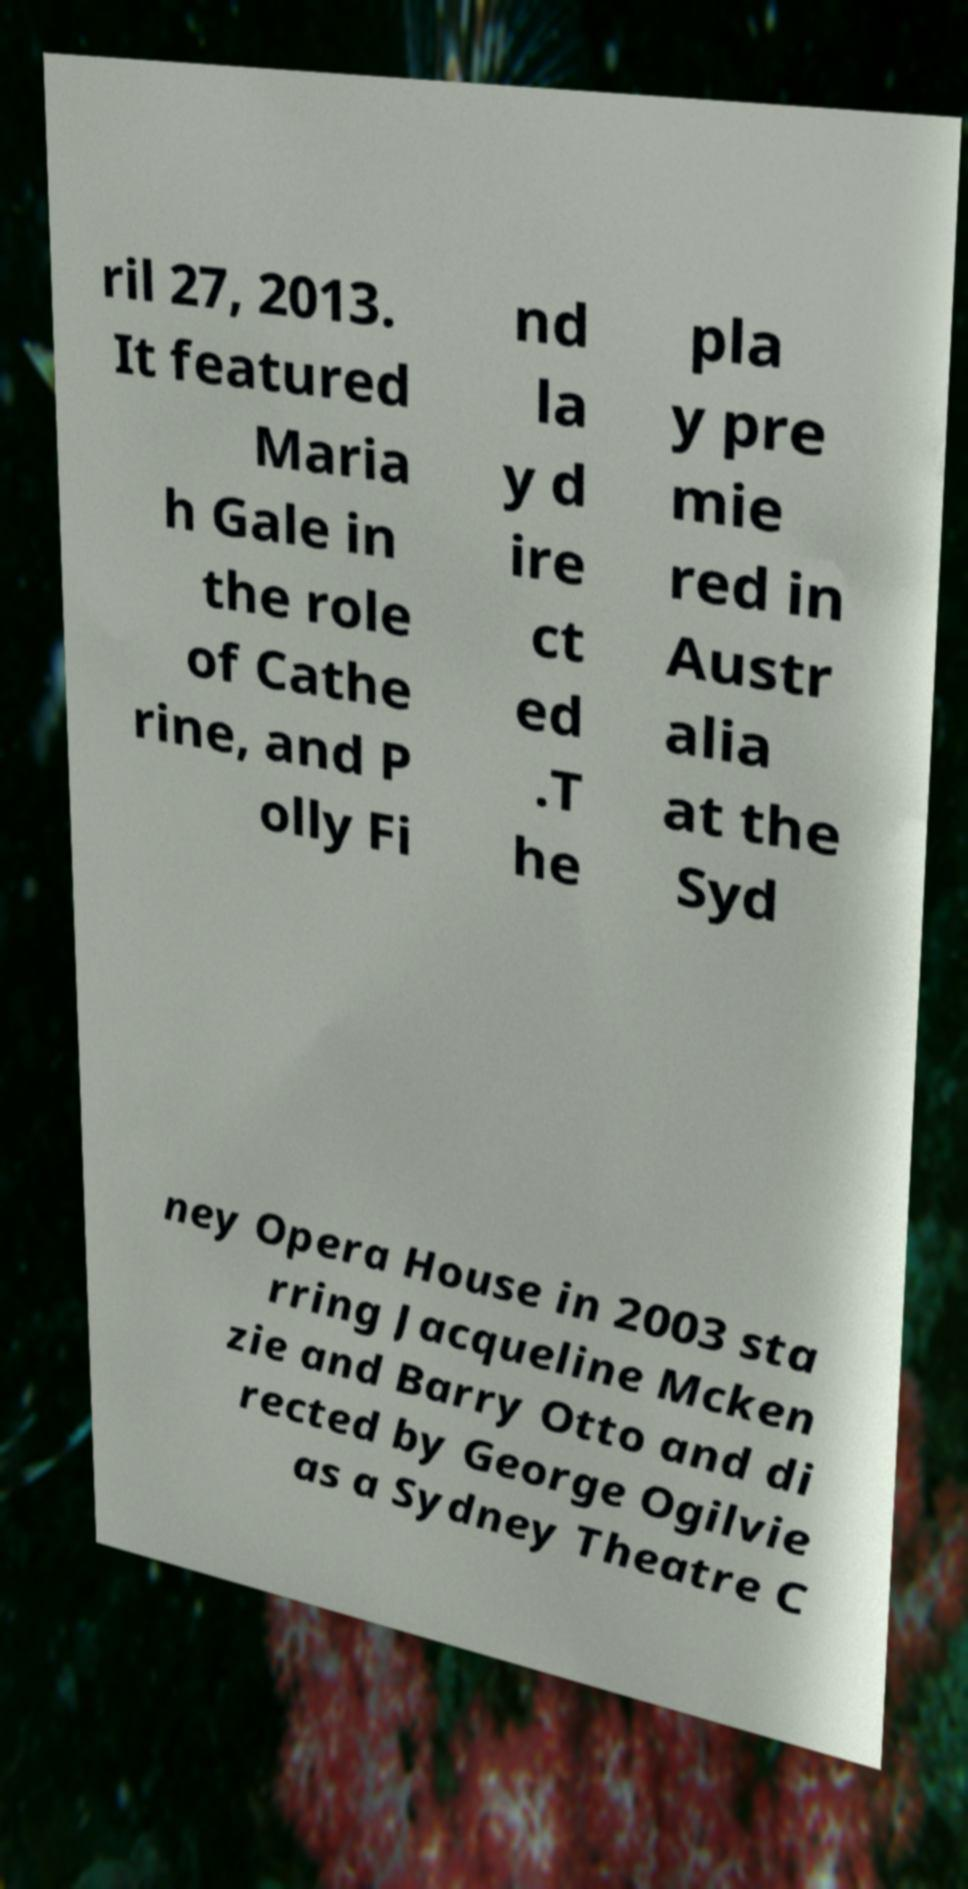Can you read and provide the text displayed in the image?This photo seems to have some interesting text. Can you extract and type it out for me? ril 27, 2013. It featured Maria h Gale in the role of Cathe rine, and P olly Fi nd la y d ire ct ed .T he pla y pre mie red in Austr alia at the Syd ney Opera House in 2003 sta rring Jacqueline Mcken zie and Barry Otto and di rected by George Ogilvie as a Sydney Theatre C 